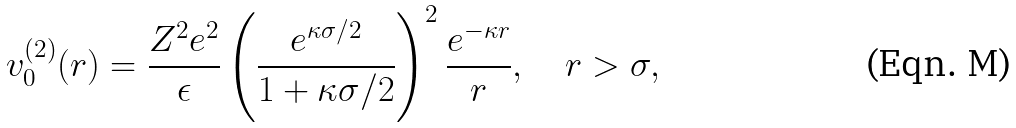<formula> <loc_0><loc_0><loc_500><loc_500>v ^ { ( 2 ) } _ { 0 } ( r ) = \frac { Z ^ { 2 } e ^ { 2 } } { \epsilon } \left ( \frac { e ^ { \kappa \sigma / 2 } } { 1 + \kappa \sigma / 2 } \right ) ^ { 2 } \frac { e ^ { - \kappa r } } { r } , \quad r > \sigma ,</formula> 